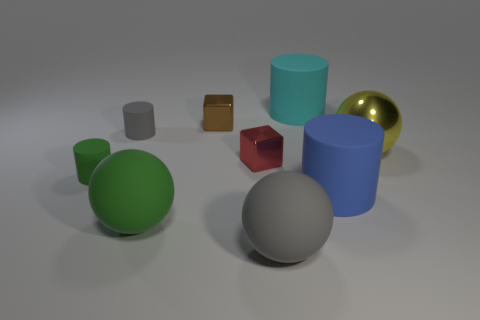Is the number of big blue cylinders that are behind the small red cube greater than the number of tiny metallic blocks?
Provide a short and direct response. No. There is a large rubber object that is behind the shiny thing that is behind the yellow shiny thing; what is its color?
Ensure brevity in your answer.  Cyan. There is a gray object that is the same size as the blue cylinder; what shape is it?
Ensure brevity in your answer.  Sphere. Are there the same number of blue things that are to the left of the blue matte cylinder and small yellow rubber blocks?
Provide a succinct answer. Yes. What is the big object that is on the left side of the big gray object that is in front of the ball that is to the right of the large cyan object made of?
Give a very brief answer. Rubber. There is a blue object that is made of the same material as the tiny green thing; what is its shape?
Provide a succinct answer. Cylinder. Is there anything else of the same color as the big shiny thing?
Provide a succinct answer. No. How many big yellow balls are behind the shiny object that is on the left side of the small shiny cube that is in front of the large yellow shiny ball?
Your response must be concise. 0. What number of blue things are tiny shiny things or big metallic balls?
Your answer should be very brief. 0. There is a brown object; does it have the same size as the metallic object to the right of the cyan cylinder?
Offer a very short reply. No. 